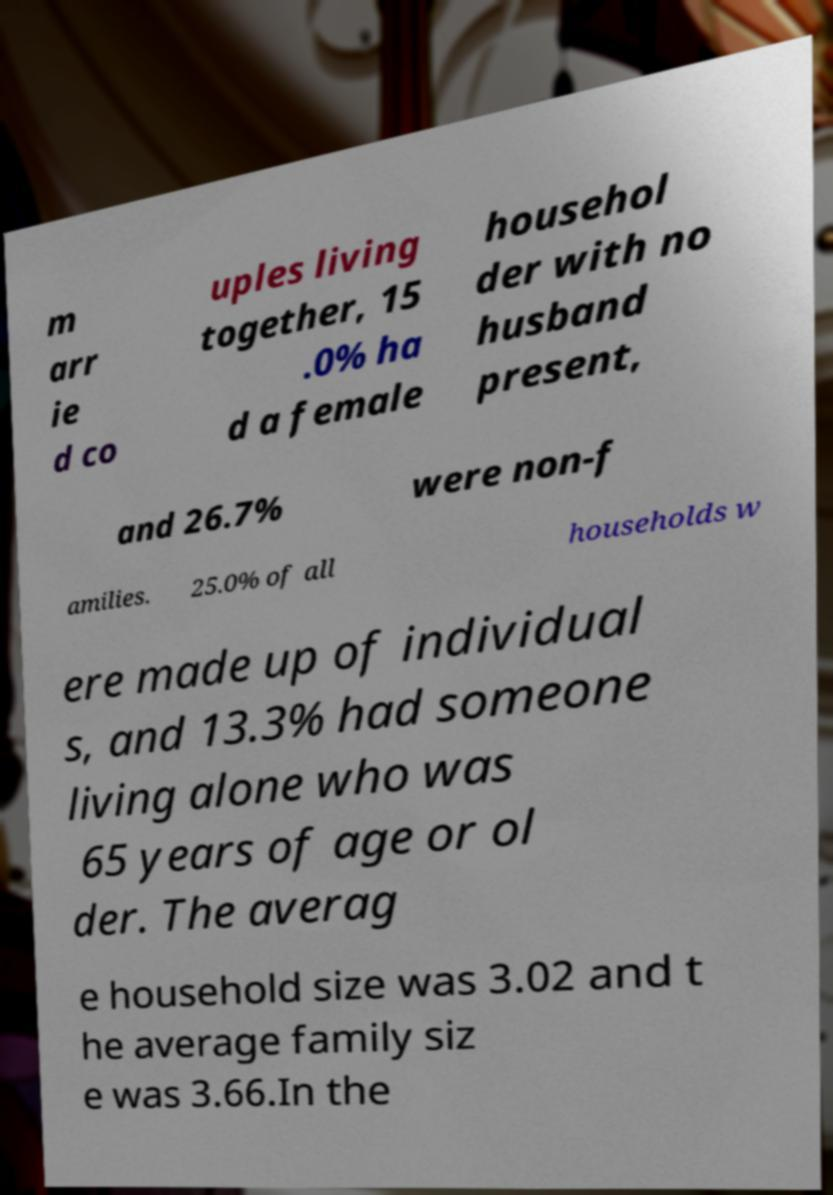Can you accurately transcribe the text from the provided image for me? m arr ie d co uples living together, 15 .0% ha d a female househol der with no husband present, and 26.7% were non-f amilies. 25.0% of all households w ere made up of individual s, and 13.3% had someone living alone who was 65 years of age or ol der. The averag e household size was 3.02 and t he average family siz e was 3.66.In the 